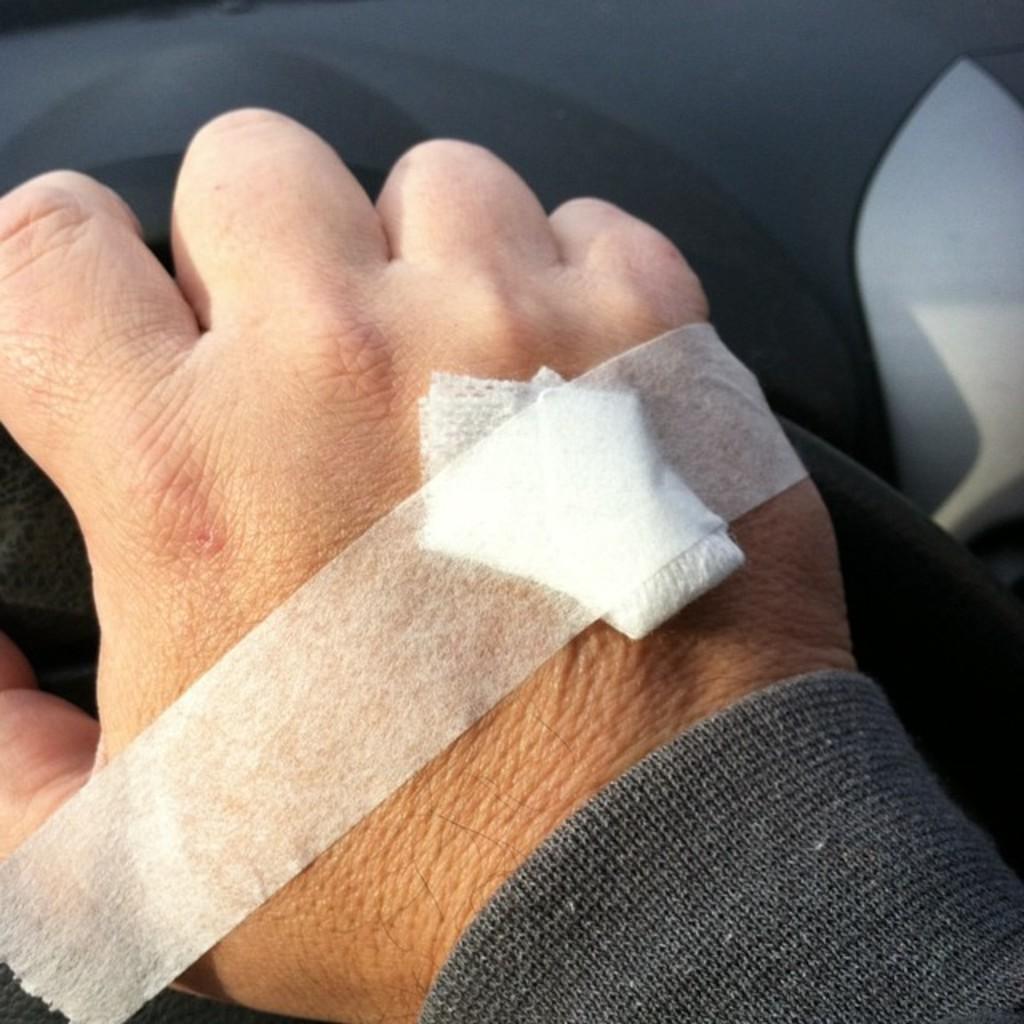How would you summarize this image in a sentence or two? In the center of the image we can see a person's hand with bandage. 